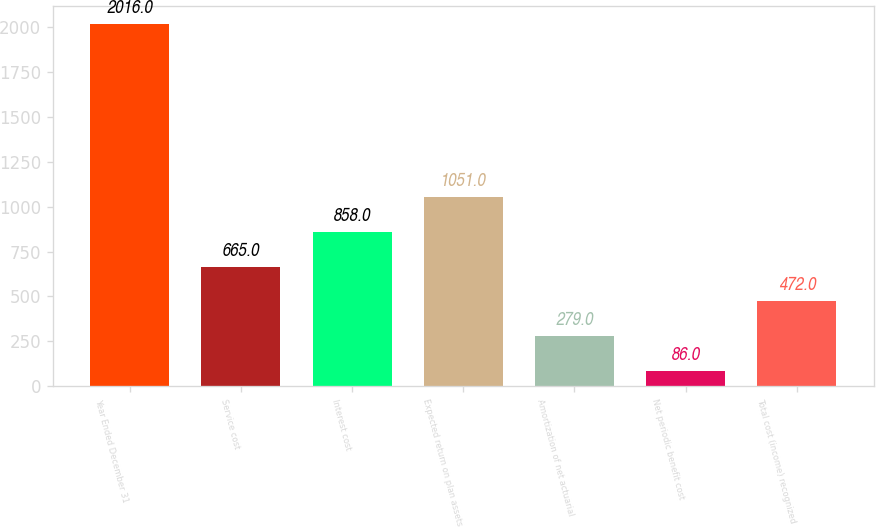Convert chart to OTSL. <chart><loc_0><loc_0><loc_500><loc_500><bar_chart><fcel>Year Ended December 31<fcel>Service cost<fcel>Interest cost<fcel>Expected return on plan assets<fcel>Amortization of net actuarial<fcel>Net periodic benefit cost<fcel>Total cost (income) recognized<nl><fcel>2016<fcel>665<fcel>858<fcel>1051<fcel>279<fcel>86<fcel>472<nl></chart> 